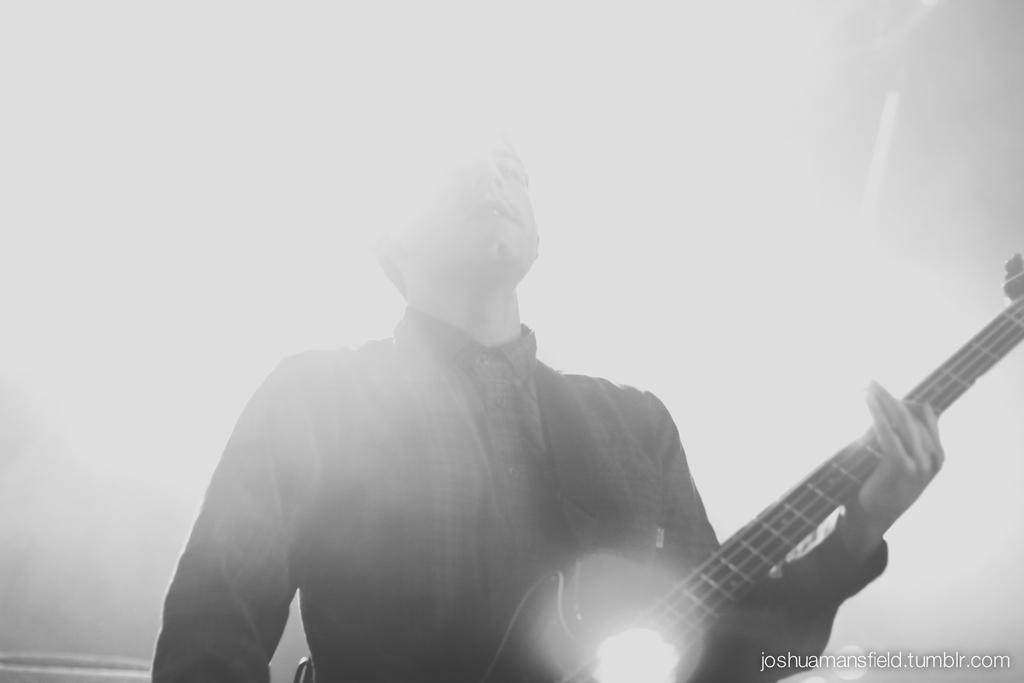What is the color scheme of the image? The image is black and white. Who is present in the image? There is a man in the image. What is the man doing in the image? The man is standing and playing a guitar. What type of cough medicine is the man holding in the image? There is no cough medicine present in the image; the man is playing a guitar. Is there a notebook visible on the ground in the image? There is no notebook visible in the image. 